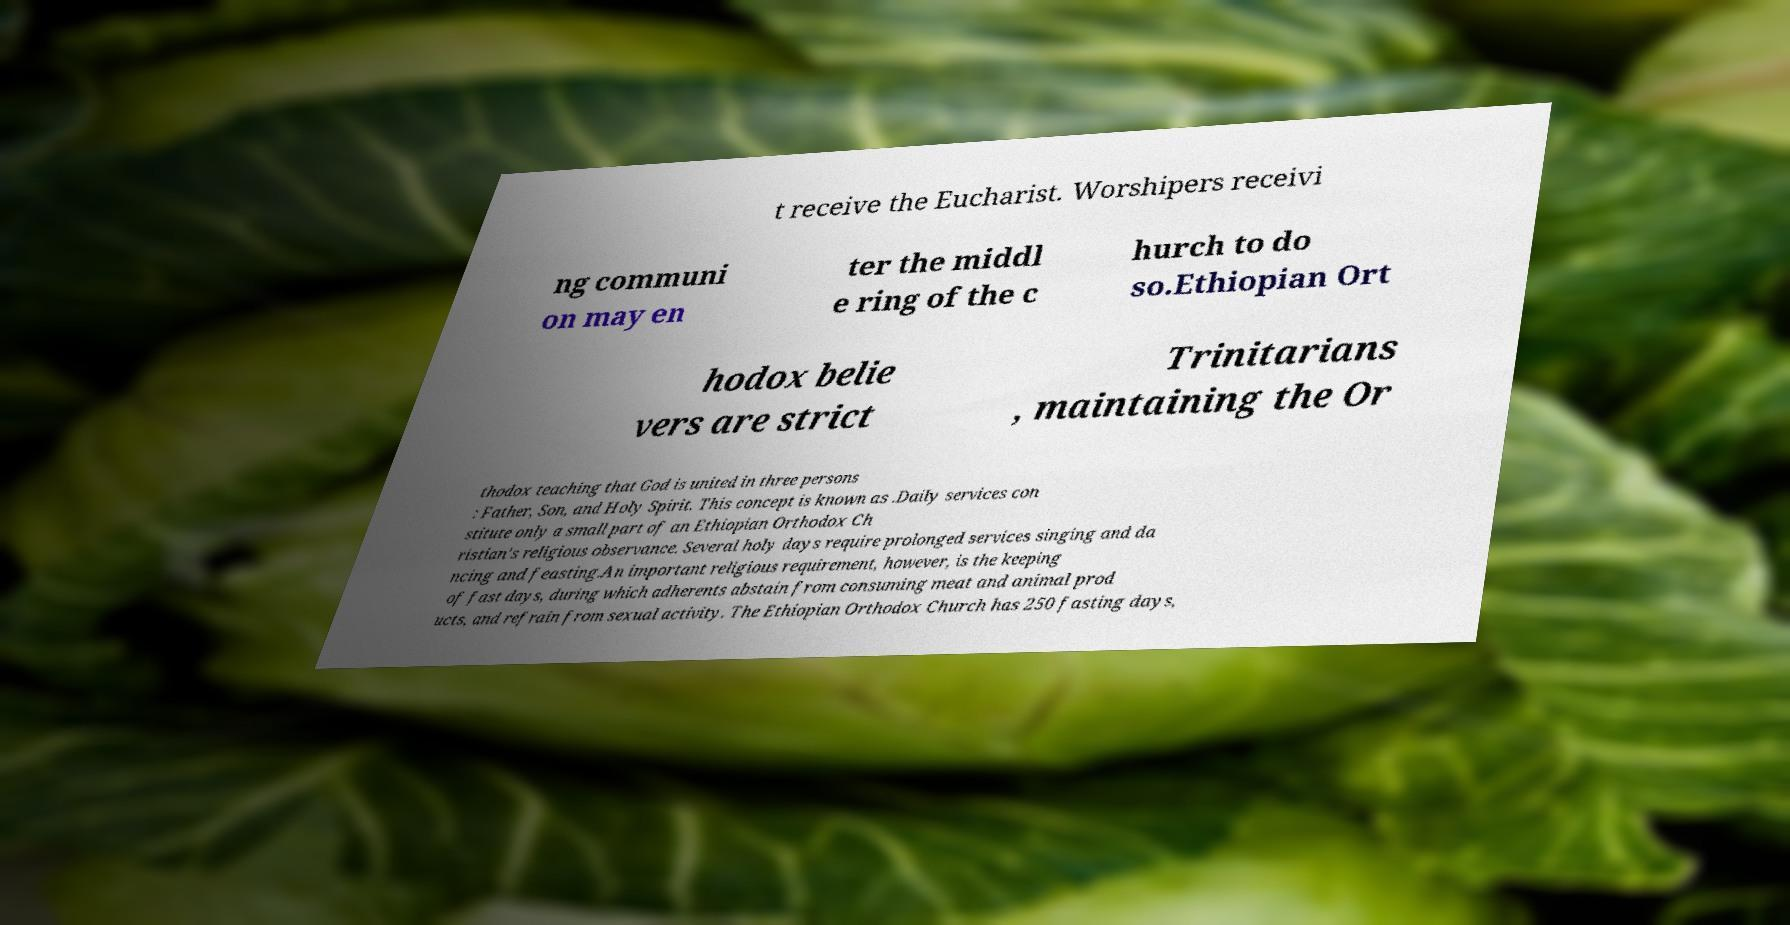Can you read and provide the text displayed in the image?This photo seems to have some interesting text. Can you extract and type it out for me? t receive the Eucharist. Worshipers receivi ng communi on may en ter the middl e ring of the c hurch to do so.Ethiopian Ort hodox belie vers are strict Trinitarians , maintaining the Or thodox teaching that God is united in three persons : Father, Son, and Holy Spirit. This concept is known as .Daily services con stitute only a small part of an Ethiopian Orthodox Ch ristian's religious observance. Several holy days require prolonged services singing and da ncing and feasting.An important religious requirement, however, is the keeping of fast days, during which adherents abstain from consuming meat and animal prod ucts, and refrain from sexual activity. The Ethiopian Orthodox Church has 250 fasting days, 